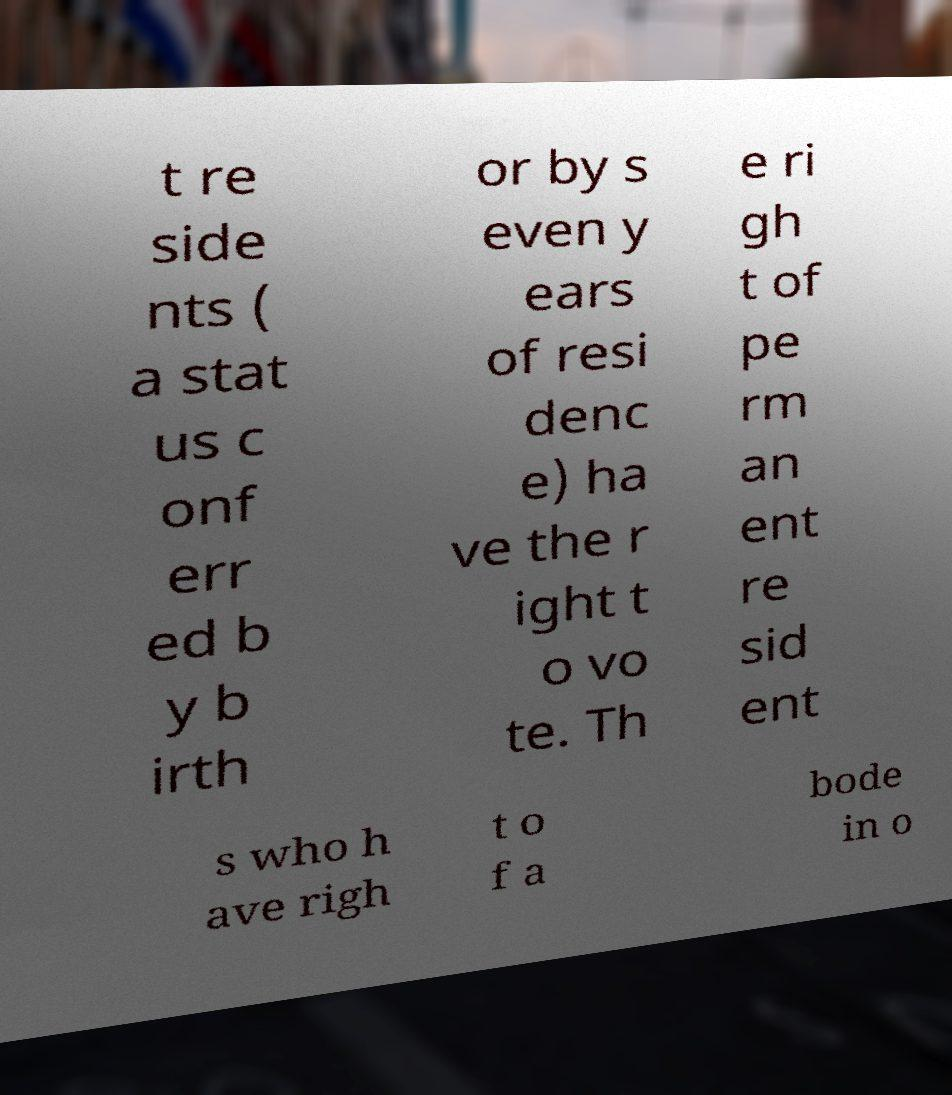I need the written content from this picture converted into text. Can you do that? t re side nts ( a stat us c onf err ed b y b irth or by s even y ears of resi denc e) ha ve the r ight t o vo te. Th e ri gh t of pe rm an ent re sid ent s who h ave righ t o f a bode in o 